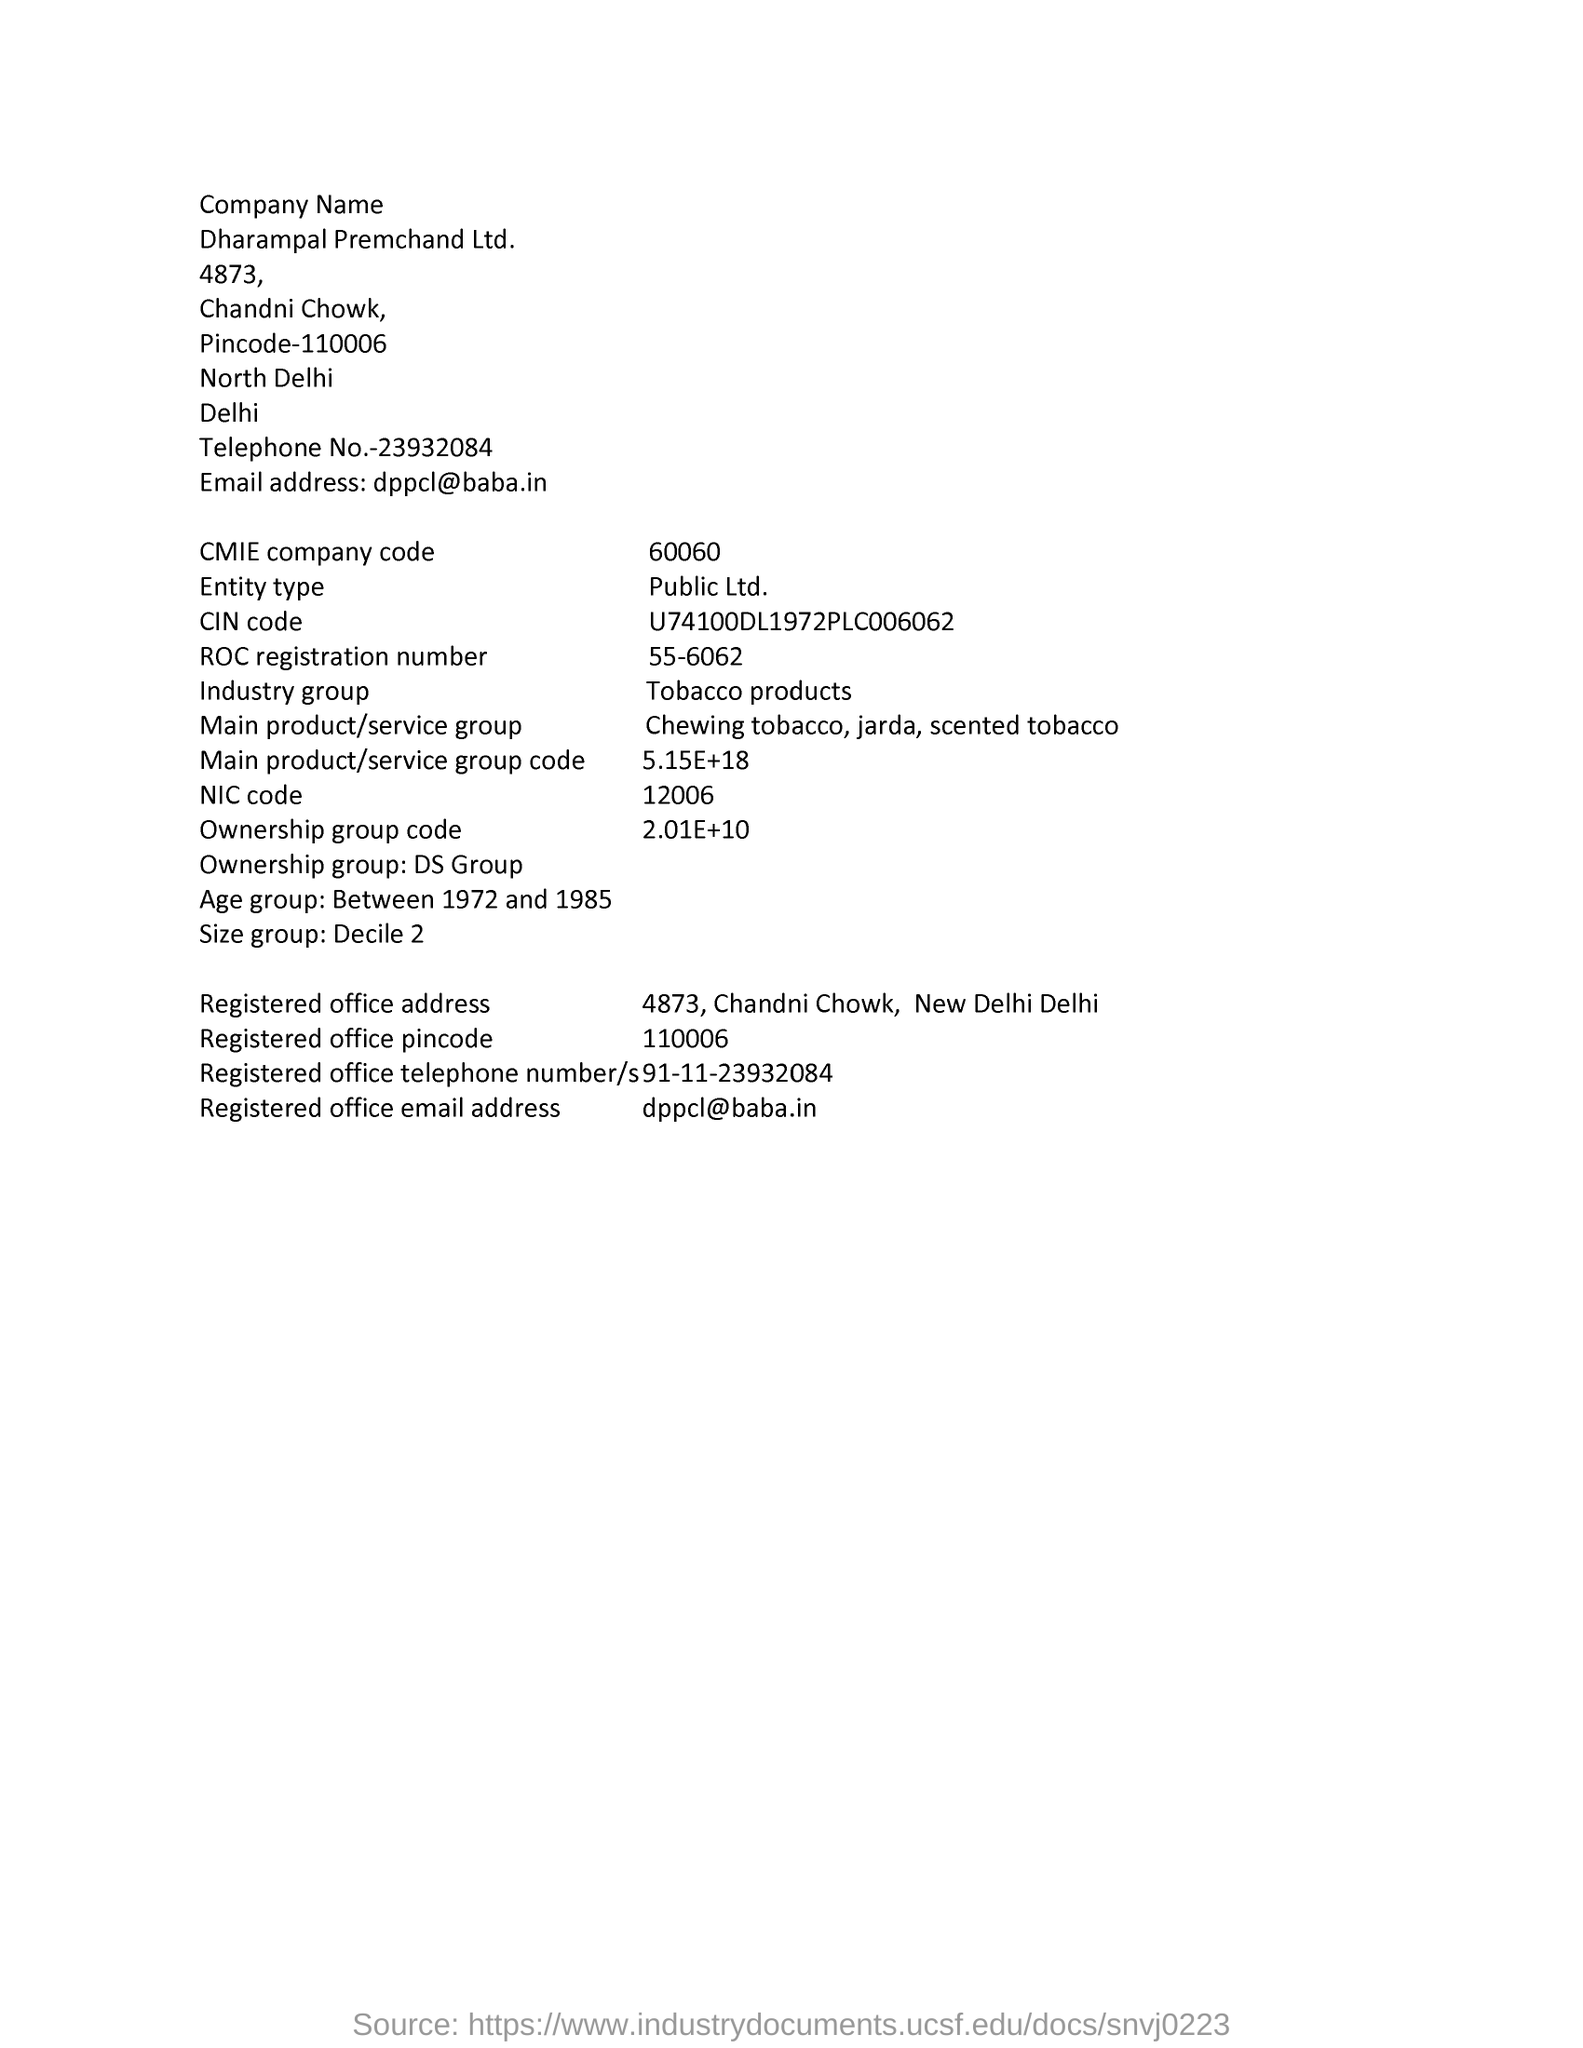Point out several critical features in this image. The industry group mentioned in the document is tobacco products. The CMIE company code mentioned in the document is 60060. Dharampal Premchand Ltd., as mentioned in this document, is the company name. The age group mentioned in this document is between 1972 and 1985. The ownership group code is 2.01E+10, as stated in the document. 